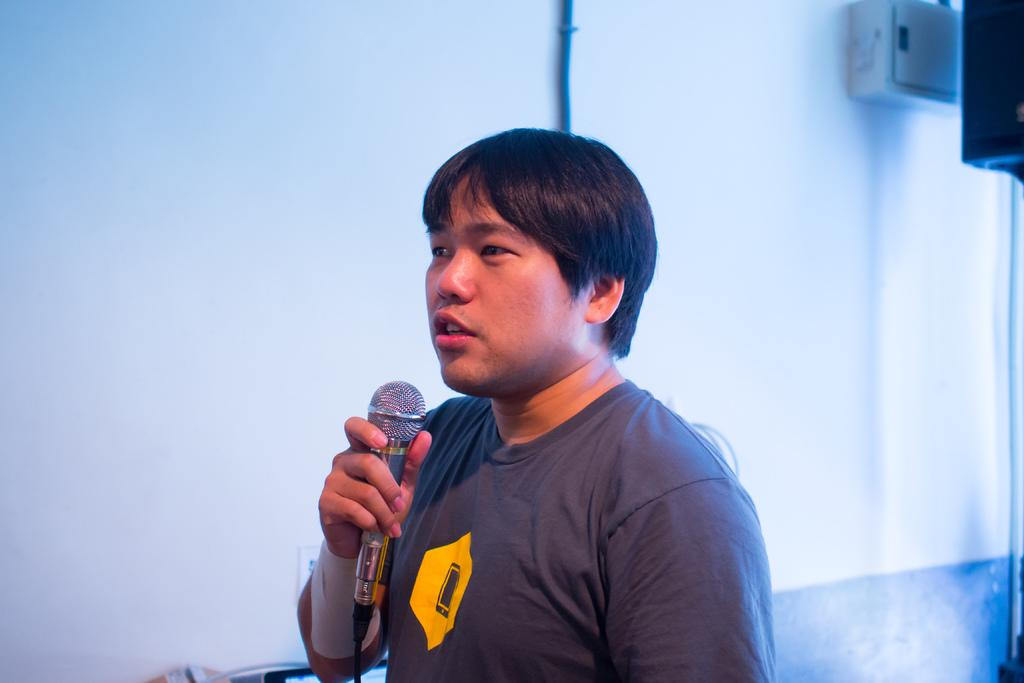Who is the main subject in the image? There is a person in the image. What is the person holding in the image? The person is holding a microphone. What is the person doing in the image? The person is talking. What can be seen in the background of the image? There is a wall and a pipe in the background of the image, as well as other objects. What type of grain is being harvested in the image? There is no grain present in the image; it features a person holding a microphone and talking. 